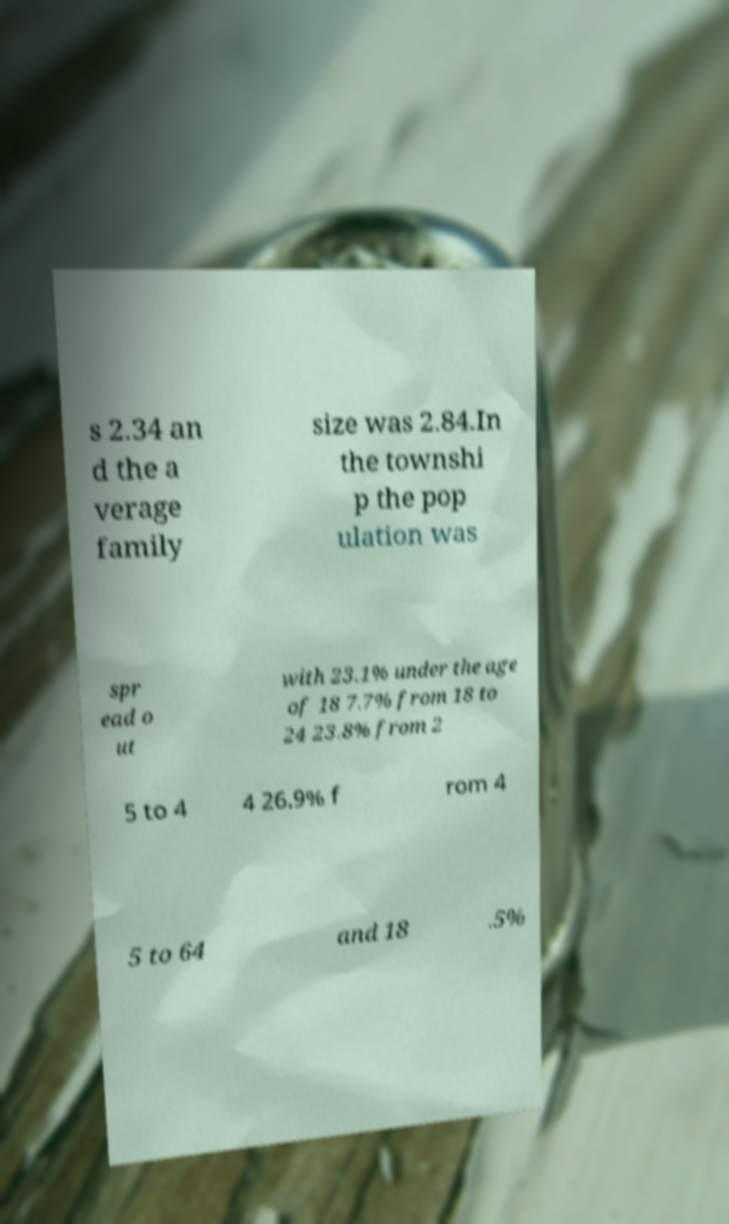Please read and relay the text visible in this image. What does it say? s 2.34 an d the a verage family size was 2.84.In the townshi p the pop ulation was spr ead o ut with 23.1% under the age of 18 7.7% from 18 to 24 23.8% from 2 5 to 4 4 26.9% f rom 4 5 to 64 and 18 .5% 